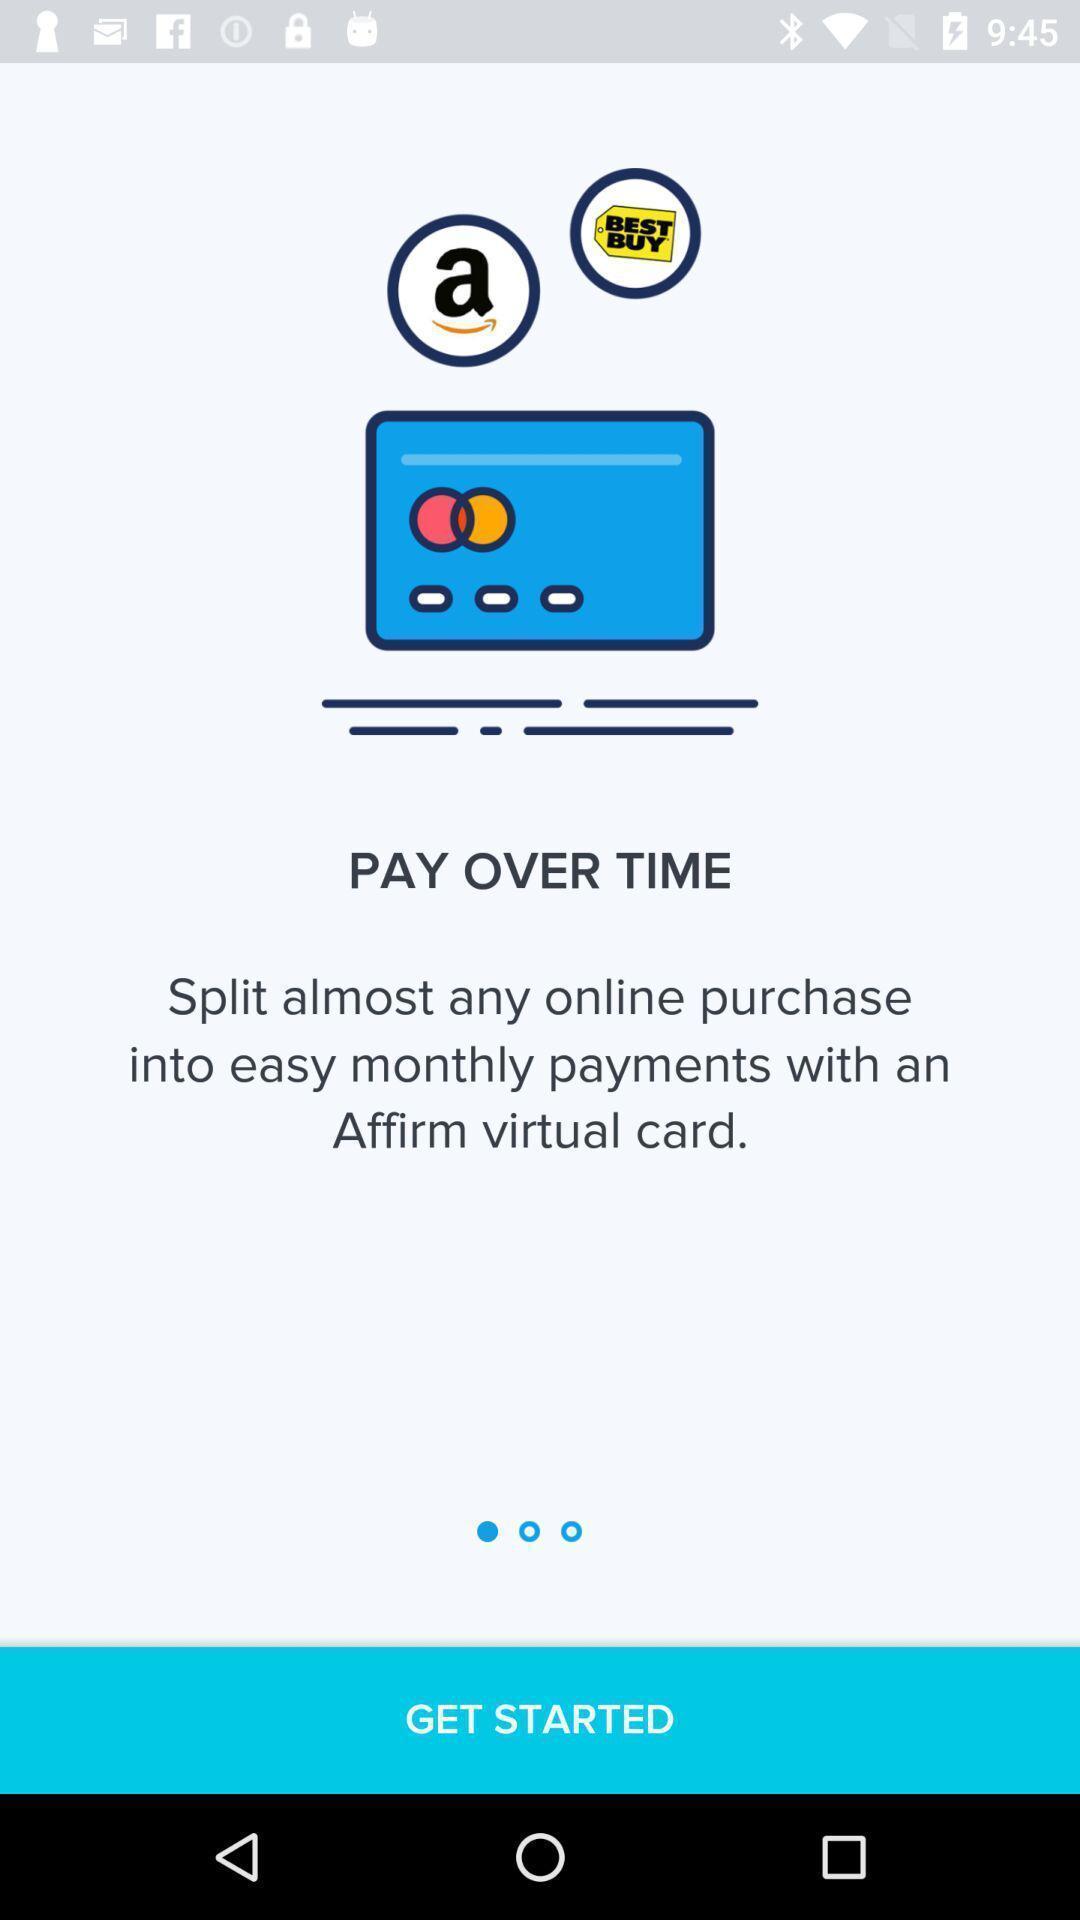Tell me about the visual elements in this screen capture. Window displaying an payment app. 